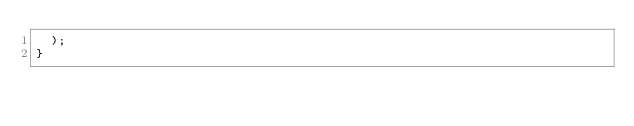<code> <loc_0><loc_0><loc_500><loc_500><_JavaScript_>  );
}
</code> 